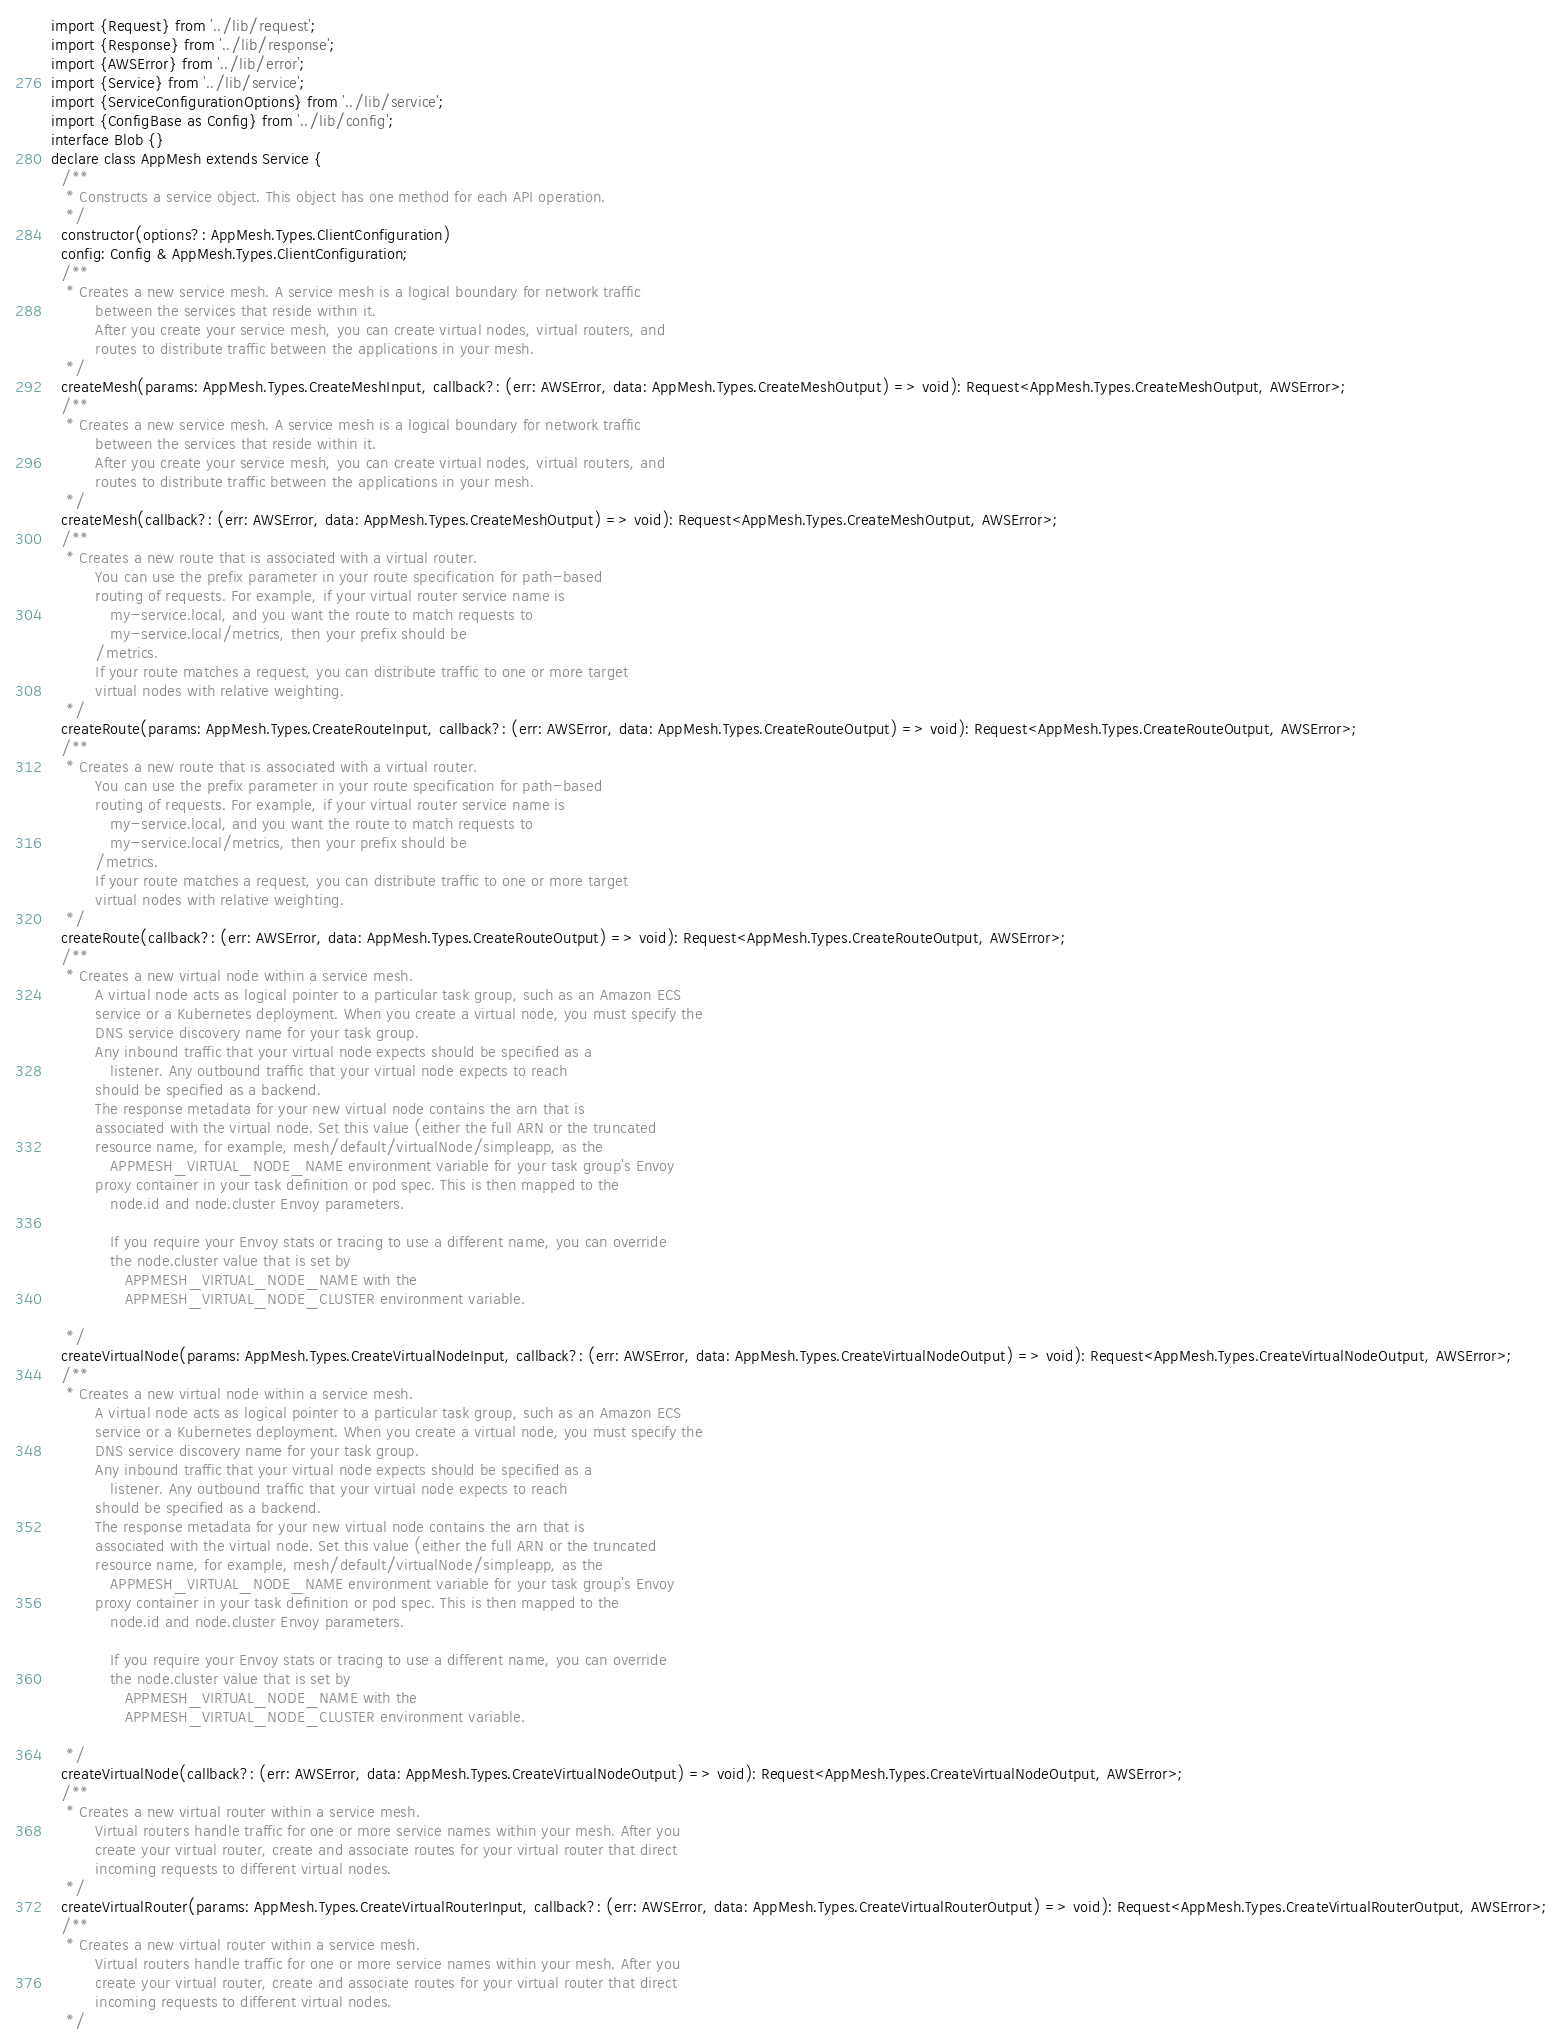<code> <loc_0><loc_0><loc_500><loc_500><_TypeScript_>import {Request} from '../lib/request';
import {Response} from '../lib/response';
import {AWSError} from '../lib/error';
import {Service} from '../lib/service';
import {ServiceConfigurationOptions} from '../lib/service';
import {ConfigBase as Config} from '../lib/config';
interface Blob {}
declare class AppMesh extends Service {
  /**
   * Constructs a service object. This object has one method for each API operation.
   */
  constructor(options?: AppMesh.Types.ClientConfiguration)
  config: Config & AppMesh.Types.ClientConfiguration;
  /**
   * Creates a new service mesh. A service mesh is a logical boundary for network traffic
         between the services that reside within it.
         After you create your service mesh, you can create virtual nodes, virtual routers, and
         routes to distribute traffic between the applications in your mesh.
   */
  createMesh(params: AppMesh.Types.CreateMeshInput, callback?: (err: AWSError, data: AppMesh.Types.CreateMeshOutput) => void): Request<AppMesh.Types.CreateMeshOutput, AWSError>;
  /**
   * Creates a new service mesh. A service mesh is a logical boundary for network traffic
         between the services that reside within it.
         After you create your service mesh, you can create virtual nodes, virtual routers, and
         routes to distribute traffic between the applications in your mesh.
   */
  createMesh(callback?: (err: AWSError, data: AppMesh.Types.CreateMeshOutput) => void): Request<AppMesh.Types.CreateMeshOutput, AWSError>;
  /**
   * Creates a new route that is associated with a virtual router.
         You can use the prefix parameter in your route specification for path-based
         routing of requests. For example, if your virtual router service name is
            my-service.local, and you want the route to match requests to
            my-service.local/metrics, then your prefix should be
         /metrics.
         If your route matches a request, you can distribute traffic to one or more target
         virtual nodes with relative weighting.
   */
  createRoute(params: AppMesh.Types.CreateRouteInput, callback?: (err: AWSError, data: AppMesh.Types.CreateRouteOutput) => void): Request<AppMesh.Types.CreateRouteOutput, AWSError>;
  /**
   * Creates a new route that is associated with a virtual router.
         You can use the prefix parameter in your route specification for path-based
         routing of requests. For example, if your virtual router service name is
            my-service.local, and you want the route to match requests to
            my-service.local/metrics, then your prefix should be
         /metrics.
         If your route matches a request, you can distribute traffic to one or more target
         virtual nodes with relative weighting.
   */
  createRoute(callback?: (err: AWSError, data: AppMesh.Types.CreateRouteOutput) => void): Request<AppMesh.Types.CreateRouteOutput, AWSError>;
  /**
   * Creates a new virtual node within a service mesh.
         A virtual node acts as logical pointer to a particular task group, such as an Amazon ECS
         service or a Kubernetes deployment. When you create a virtual node, you must specify the
         DNS service discovery name for your task group.
         Any inbound traffic that your virtual node expects should be specified as a
            listener. Any outbound traffic that your virtual node expects to reach
         should be specified as a backend.
         The response metadata for your new virtual node contains the arn that is
         associated with the virtual node. Set this value (either the full ARN or the truncated
         resource name, for example, mesh/default/virtualNode/simpleapp, as the
            APPMESH_VIRTUAL_NODE_NAME environment variable for your task group's Envoy
         proxy container in your task definition or pod spec. This is then mapped to the
            node.id and node.cluster Envoy parameters.
         
            If you require your Envoy stats or tracing to use a different name, you can override
            the node.cluster value that is set by
               APPMESH_VIRTUAL_NODE_NAME with the
               APPMESH_VIRTUAL_NODE_CLUSTER environment variable.
         
   */
  createVirtualNode(params: AppMesh.Types.CreateVirtualNodeInput, callback?: (err: AWSError, data: AppMesh.Types.CreateVirtualNodeOutput) => void): Request<AppMesh.Types.CreateVirtualNodeOutput, AWSError>;
  /**
   * Creates a new virtual node within a service mesh.
         A virtual node acts as logical pointer to a particular task group, such as an Amazon ECS
         service or a Kubernetes deployment. When you create a virtual node, you must specify the
         DNS service discovery name for your task group.
         Any inbound traffic that your virtual node expects should be specified as a
            listener. Any outbound traffic that your virtual node expects to reach
         should be specified as a backend.
         The response metadata for your new virtual node contains the arn that is
         associated with the virtual node. Set this value (either the full ARN or the truncated
         resource name, for example, mesh/default/virtualNode/simpleapp, as the
            APPMESH_VIRTUAL_NODE_NAME environment variable for your task group's Envoy
         proxy container in your task definition or pod spec. This is then mapped to the
            node.id and node.cluster Envoy parameters.
         
            If you require your Envoy stats or tracing to use a different name, you can override
            the node.cluster value that is set by
               APPMESH_VIRTUAL_NODE_NAME with the
               APPMESH_VIRTUAL_NODE_CLUSTER environment variable.
         
   */
  createVirtualNode(callback?: (err: AWSError, data: AppMesh.Types.CreateVirtualNodeOutput) => void): Request<AppMesh.Types.CreateVirtualNodeOutput, AWSError>;
  /**
   * Creates a new virtual router within a service mesh.
         Virtual routers handle traffic for one or more service names within your mesh. After you
         create your virtual router, create and associate routes for your virtual router that direct
         incoming requests to different virtual nodes.
   */
  createVirtualRouter(params: AppMesh.Types.CreateVirtualRouterInput, callback?: (err: AWSError, data: AppMesh.Types.CreateVirtualRouterOutput) => void): Request<AppMesh.Types.CreateVirtualRouterOutput, AWSError>;
  /**
   * Creates a new virtual router within a service mesh.
         Virtual routers handle traffic for one or more service names within your mesh. After you
         create your virtual router, create and associate routes for your virtual router that direct
         incoming requests to different virtual nodes.
   */</code> 